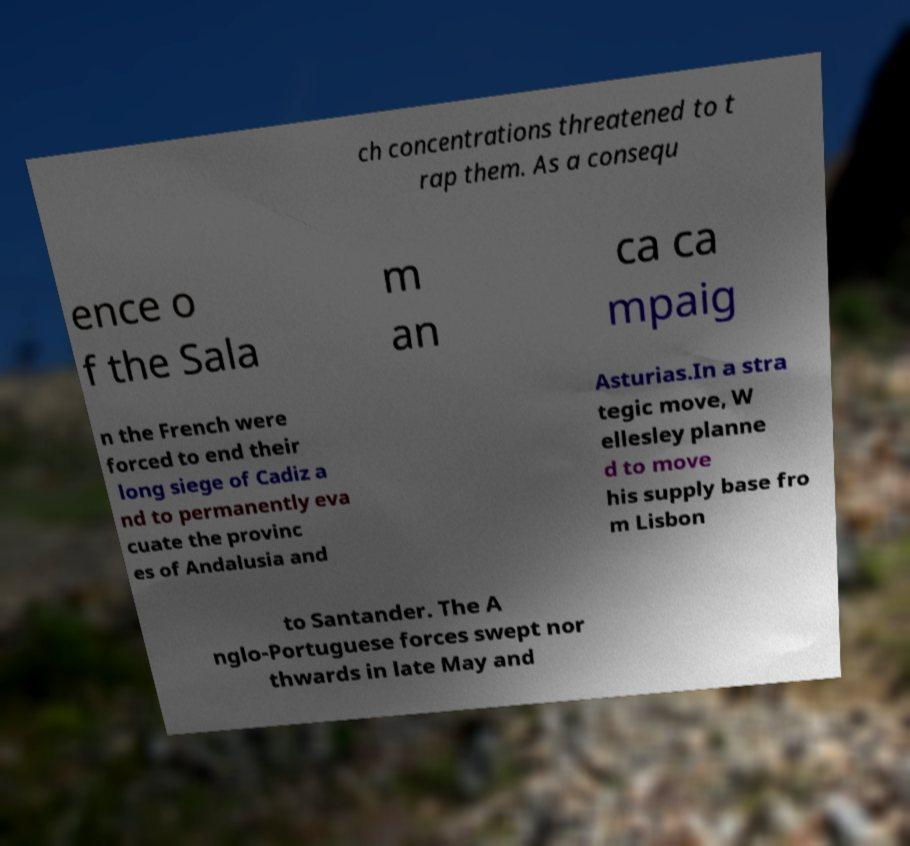Please identify and transcribe the text found in this image. ch concentrations threatened to t rap them. As a consequ ence o f the Sala m an ca ca mpaig n the French were forced to end their long siege of Cadiz a nd to permanently eva cuate the provinc es of Andalusia and Asturias.In a stra tegic move, W ellesley planne d to move his supply base fro m Lisbon to Santander. The A nglo-Portuguese forces swept nor thwards in late May and 